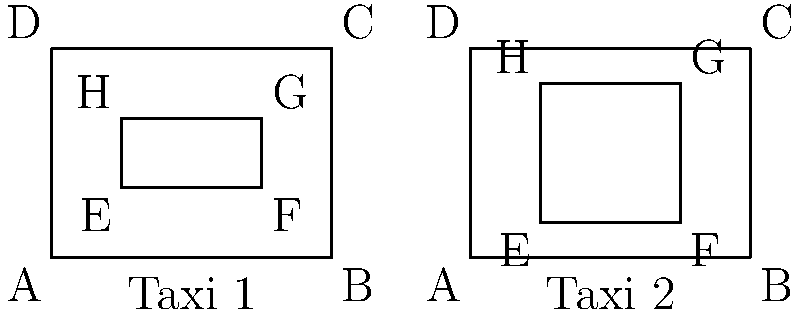In your self-driving taxi service, you have two different vehicle layouts as shown above. To ensure passenger safety and comfort, you need to determine if the seating arrangements (represented by rectangles EFGH) in both taxis are congruent. Which criteria would you use to prove the congruence of these seating arrangements? To determine if the seating arrangements (rectangles EFGH) in both taxis are congruent, we need to follow these steps:

1. Recall the definition of congruent shapes: Two shapes are congruent if they have the same size and shape.

2. For rectangles to be congruent, they must have:
   a) Equal lengths of corresponding sides
   b) Equal measures of corresponding angles (all 90° for rectangles)

3. Let's compare the rectangles EFGH in both taxis:

   Taxi 1:
   - EF = HG = 2 units
   - EH = FG = 1 unit

   Taxi 2:
   - EF = HG = 2 units
   - EH = FG = 2 units

4. We can see that while the width (EF and HG) is the same in both taxis, the height (EH and FG) is different.

5. Since the dimensions are not the same, we can conclude that the seating arrangements are not congruent.

To prove congruence, we would need to show that:
a) All corresponding sides are equal: EF = E'F', FG = F'G', GH = G'H', and EH = E'H'
b) All corresponding angles are equal (which is always true for rectangles)

In this case, we've shown that the rectangles fail the first criterion, as EH ≠ E'H'.
Answer: Equal corresponding sides and angles 